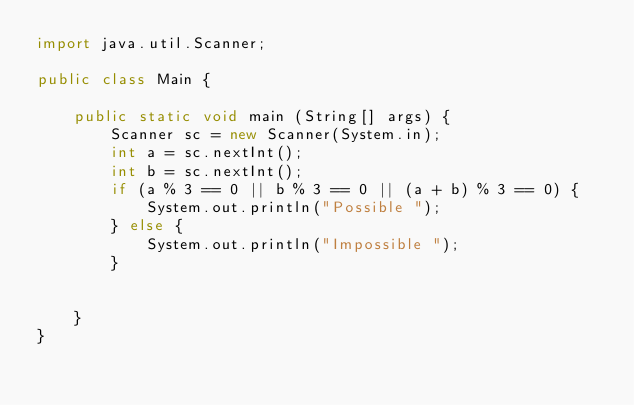Convert code to text. <code><loc_0><loc_0><loc_500><loc_500><_Java_>import java.util.Scanner;

public class Main {

	public static void main (String[] args) {
		Scanner sc = new Scanner(System.in);
		int a = sc.nextInt();
		int b = sc.nextInt();
		if (a % 3 == 0 || b % 3 == 0 || (a + b) % 3 == 0) {
			System.out.println("Possible ");
		} else {
			System.out.println("Impossible ");
		}


	}
}</code> 